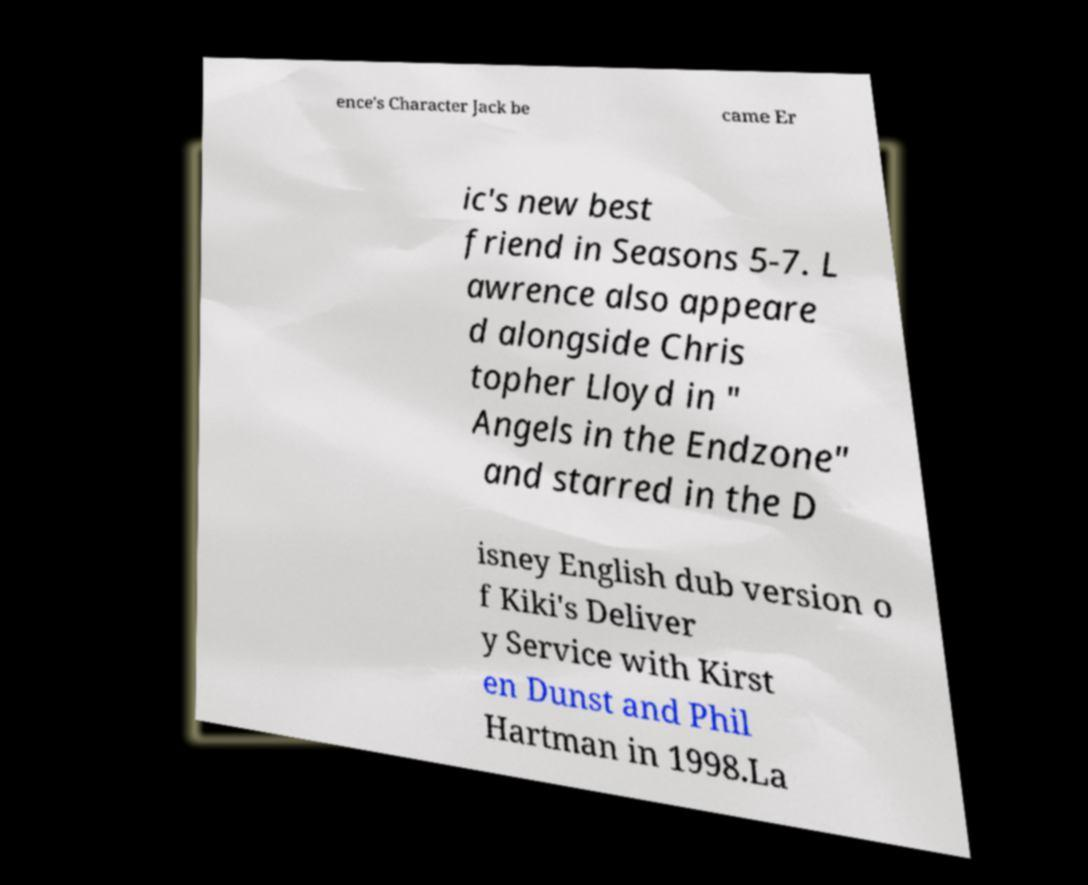Could you extract and type out the text from this image? ence's Character Jack be came Er ic's new best friend in Seasons 5-7. L awrence also appeare d alongside Chris topher Lloyd in " Angels in the Endzone" and starred in the D isney English dub version o f Kiki's Deliver y Service with Kirst en Dunst and Phil Hartman in 1998.La 